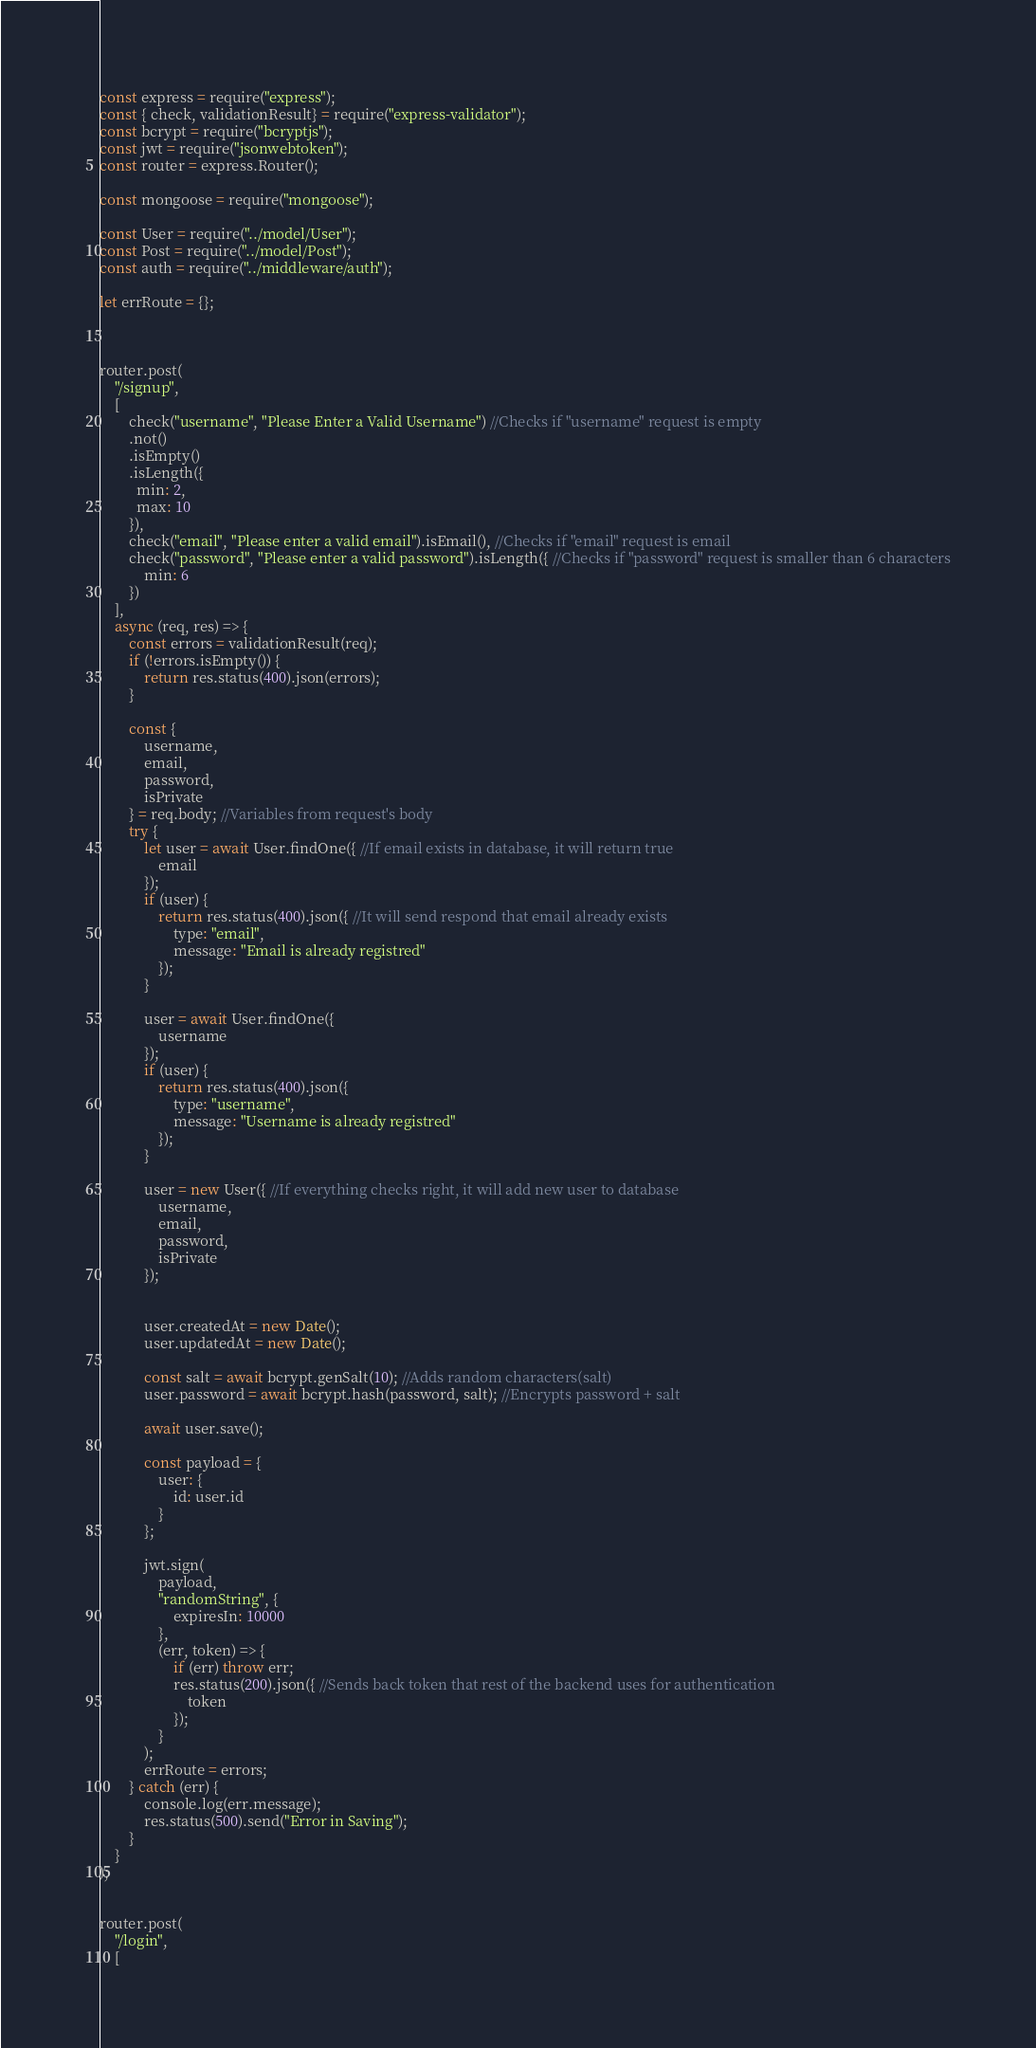Convert code to text. <code><loc_0><loc_0><loc_500><loc_500><_JavaScript_>const express = require("express");
const { check, validationResult} = require("express-validator");
const bcrypt = require("bcryptjs");
const jwt = require("jsonwebtoken");
const router = express.Router();

const mongoose = require("mongoose");

const User = require("../model/User");
const Post = require("../model/Post");
const auth = require("../middleware/auth");

let errRoute = {};



router.post(
    "/signup",
    [
        check("username", "Please Enter a Valid Username") //Checks if "username" request is empty
        .not()
        .isEmpty()
        .isLength({
          min: 2,
          max: 10
        }),
        check("email", "Please enter a valid email").isEmail(), //Checks if "email" request is email
        check("password", "Please enter a valid password").isLength({ //Checks if "password" request is smaller than 6 characters
            min: 6
        })
    ],
    async (req, res) => {
        const errors = validationResult(req);
        if (!errors.isEmpty()) {
            return res.status(400).json(errors);
        }

        const {
            username,
            email,
            password,
            isPrivate
        } = req.body; //Variables from request's body
        try {
            let user = await User.findOne({ //If email exists in database, it will return true
                email 
            });
            if (user) {
                return res.status(400).json({ //It will send respond that email already exists
                    type: "email",
                    message: "Email is already registred"
                });
            }

            user = await User.findOne({ 
                username
            });
            if (user) {
                return res.status(400).json({
                    type: "username",
                    message: "Username is already registred"
                });
            }

            user = new User({ //If everything checks right, it will add new user to database
                username,
                email,
                password,
                isPrivate
            });

            
            user.createdAt = new Date();
            user.updatedAt = new Date();

            const salt = await bcrypt.genSalt(10); //Adds random characters(salt) 
            user.password = await bcrypt.hash(password, salt); //Encrypts password + salt

            await user.save();

            const payload = {
                user: {
                    id: user.id
                }
            };

            jwt.sign(
                payload,
                "randomString", {
                    expiresIn: 10000
                },
                (err, token) => {
                    if (err) throw err;
                    res.status(200).json({ //Sends back token that rest of the backend uses for authentication
                        token
                    });
                }
            );
            errRoute = errors;
        } catch (err) {
            console.log(err.message);
            res.status(500).send("Error in Saving");
        }
    }
);


router.post(
    "/login",
    [</code> 